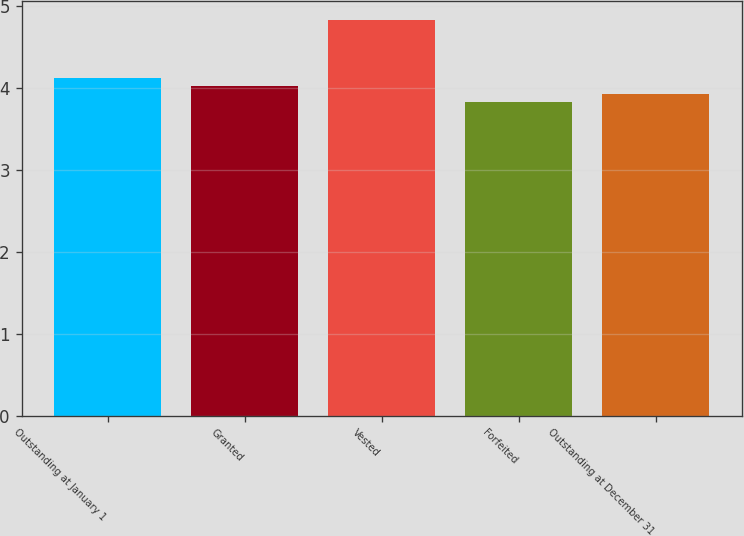<chart> <loc_0><loc_0><loc_500><loc_500><bar_chart><fcel>Outstanding at January 1<fcel>Granted<fcel>Vested<fcel>Forfeited<fcel>Outstanding at December 31<nl><fcel>4.12<fcel>4.02<fcel>4.82<fcel>3.82<fcel>3.92<nl></chart> 